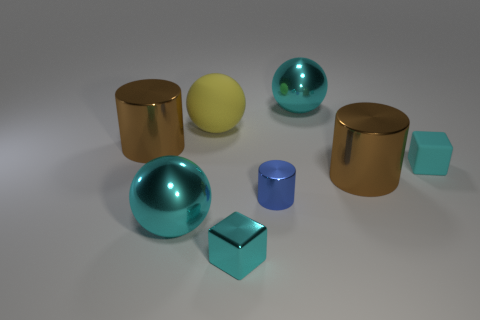There is a cyan thing behind the yellow object; is it the same size as the yellow rubber sphere?
Make the answer very short. Yes. Are there any tiny blocks that have the same color as the big matte object?
Your response must be concise. No. How many things are either cyan shiny things in front of the small metallic cylinder or large metal objects that are right of the yellow ball?
Offer a very short reply. 4. Do the large rubber ball and the tiny metal cylinder have the same color?
Keep it short and to the point. No. There is a small object that is the same color as the metal cube; what is its material?
Ensure brevity in your answer.  Rubber. Is the number of large rubber balls in front of the yellow matte ball less than the number of tiny metallic things that are on the right side of the tiny metal cylinder?
Offer a terse response. No. Do the large yellow sphere and the blue object have the same material?
Provide a succinct answer. No. What size is the sphere that is both left of the blue metal cylinder and behind the tiny rubber thing?
Keep it short and to the point. Large. What shape is the cyan shiny thing that is the same size as the blue cylinder?
Offer a terse response. Cube. There is a large brown cylinder that is to the left of the brown cylinder to the right of the cyan metal ball in front of the yellow matte ball; what is its material?
Provide a short and direct response. Metal. 